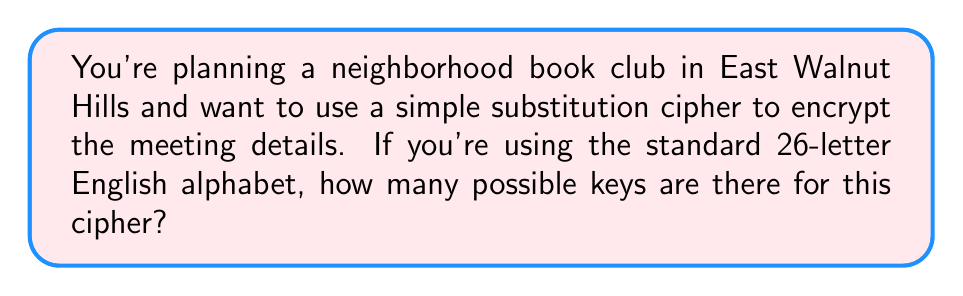Could you help me with this problem? Let's approach this step-by-step:

1) In a simple substitution cipher, each letter of the plaintext alphabet is replaced by a letter from the ciphertext alphabet.

2) We're using the standard 26-letter English alphabet.

3) For the first letter of the ciphertext alphabet, we have 26 choices.

4) For the second letter, we have 25 choices (because we can't use the letter we used for the first position).

5) For the third letter, we have 24 choices, and so on.

6) This continues until we reach the last letter, for which we have only 1 choice left.

7) This scenario describes a permutation of 26 elements.

8) The number of permutations of n distinct objects is given by the factorial of n, denoted as n!

9) Therefore, the number of possible keys is:

   $$26! = 26 \times 25 \times 24 \times ... \times 2 \times 1$$

10) Calculating this out:
    
    $$26! = 403,291,461,126,605,635,584,000,000$$

This incredibly large number demonstrates why simple substitution ciphers, while easy to implement, can be secure against brute-force attacks if the message is short enough.
Answer: $26!$ or $403,291,461,126,605,635,584,000,000$ 